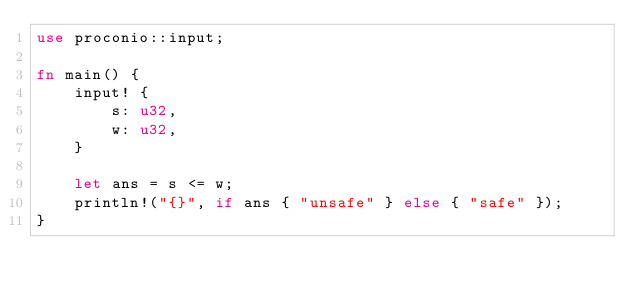Convert code to text. <code><loc_0><loc_0><loc_500><loc_500><_Rust_>use proconio::input;

fn main() {
    input! {
        s: u32,
        w: u32,
    }

    let ans = s <= w;
    println!("{}", if ans { "unsafe" } else { "safe" });
}
</code> 